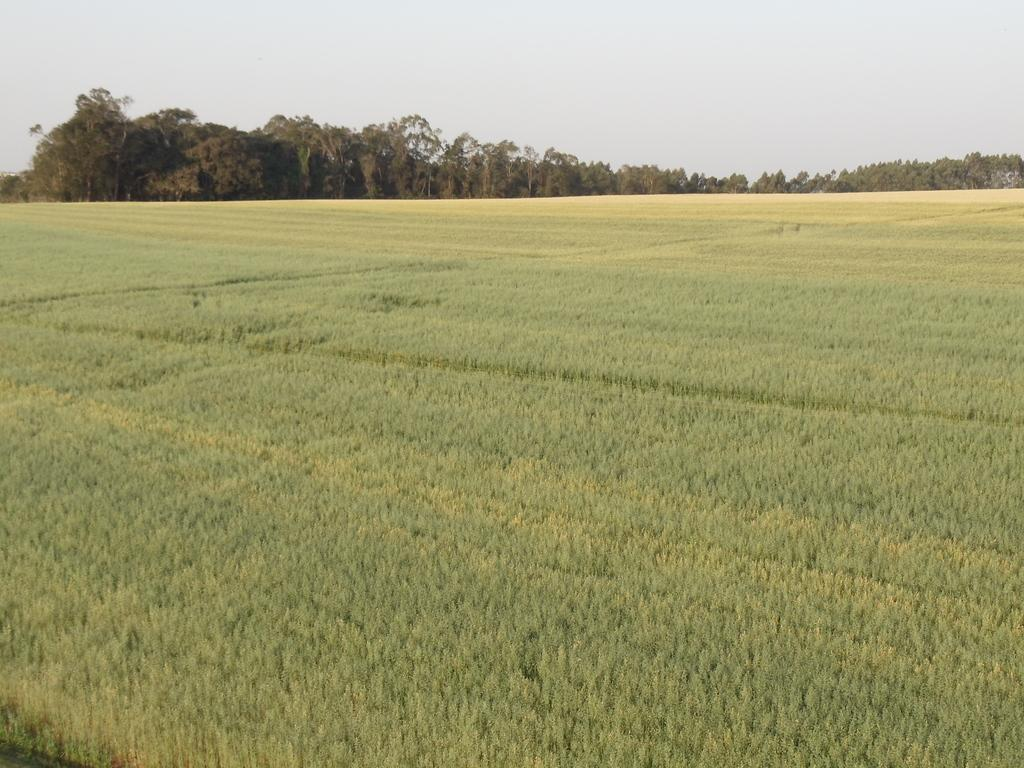What is the main subject of the image? The main subject of the image is a form. How much of the image is occupied by the form? The form takes up a significant portion of the image. What can be seen in the background of the image? There are trees in the background of the image. What type of vegetation is visible at the bottom of the image? There is grass at the bottom of the image. How many matches are visible in the image? There are no matches present in the image. What type of air is visible in the image? The image does not depict any specific type of air; it is a form with a background of trees and grass. 